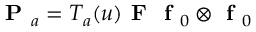<formula> <loc_0><loc_0><loc_500><loc_500>P _ { a } = T _ { a } ( u ) F f _ { 0 } \otimes f _ { 0 }</formula> 